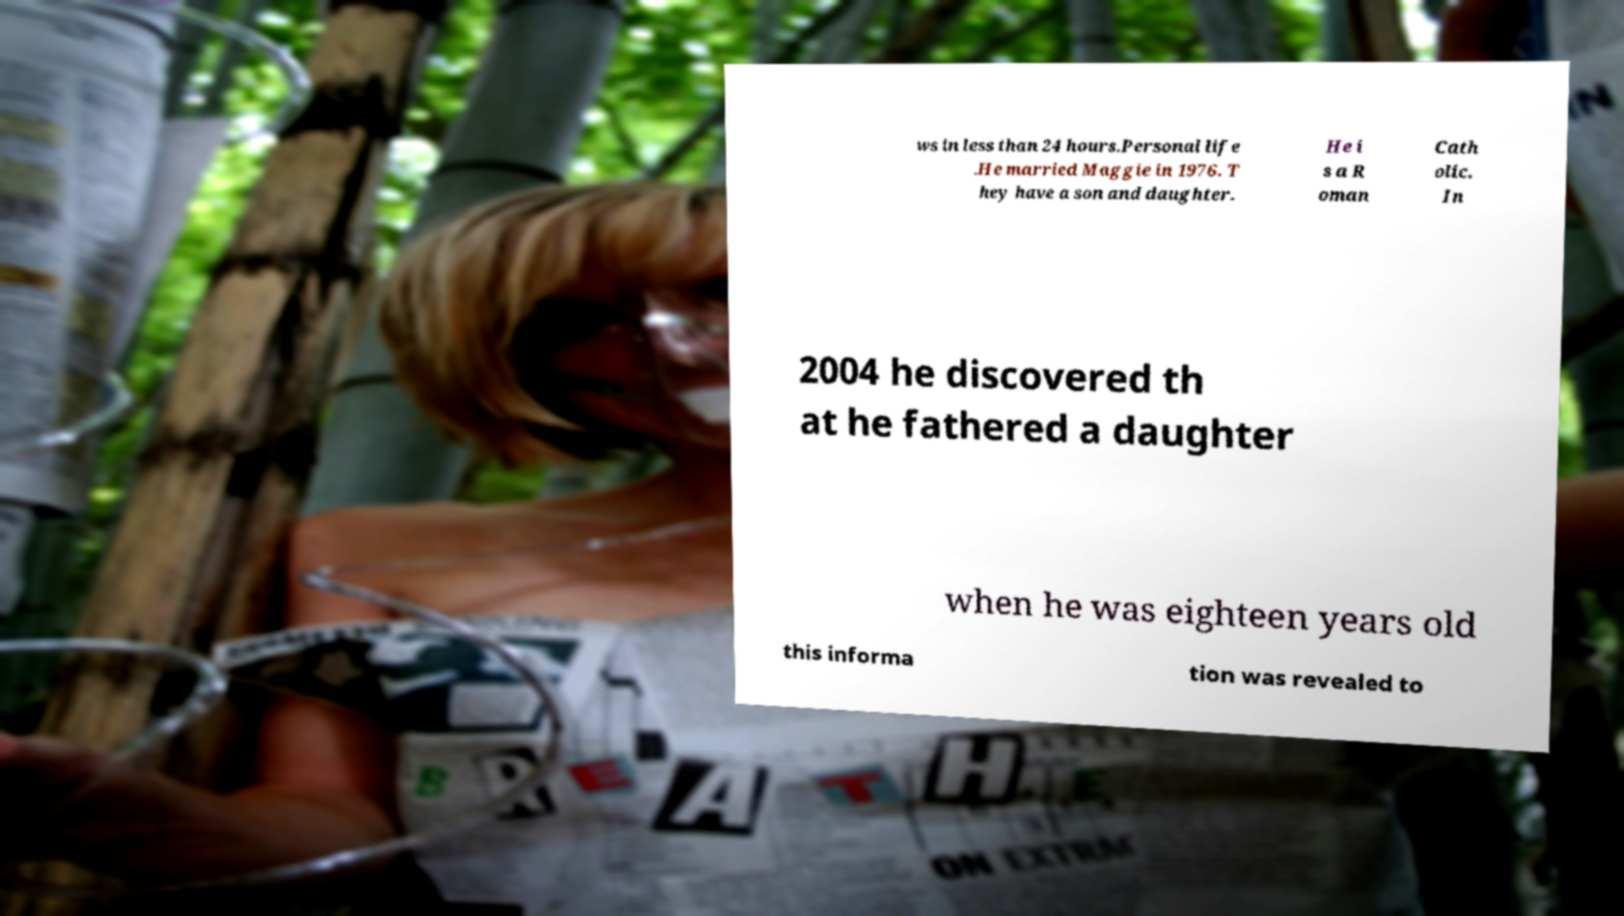Could you extract and type out the text from this image? ws in less than 24 hours.Personal life .He married Maggie in 1976. T hey have a son and daughter. He i s a R oman Cath olic. In 2004 he discovered th at he fathered a daughter when he was eighteen years old this informa tion was revealed to 